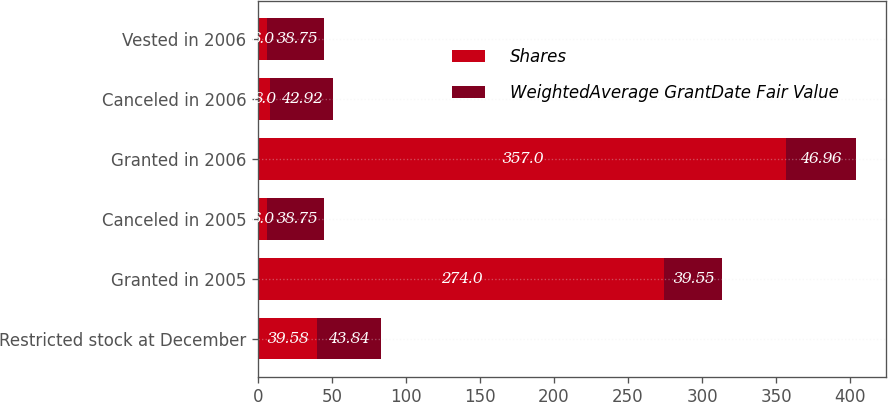Convert chart to OTSL. <chart><loc_0><loc_0><loc_500><loc_500><stacked_bar_chart><ecel><fcel>Restricted stock at December<fcel>Granted in 2005<fcel>Canceled in 2005<fcel>Granted in 2006<fcel>Canceled in 2006<fcel>Vested in 2006<nl><fcel>Shares<fcel>39.58<fcel>274<fcel>6<fcel>357<fcel>8<fcel>6<nl><fcel>WeightedAverage GrantDate Fair Value<fcel>43.84<fcel>39.55<fcel>38.75<fcel>46.96<fcel>42.92<fcel>38.75<nl></chart> 